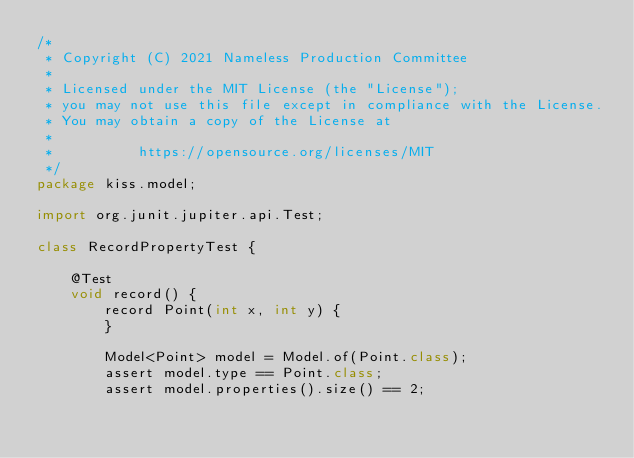<code> <loc_0><loc_0><loc_500><loc_500><_Java_>/*
 * Copyright (C) 2021 Nameless Production Committee
 *
 * Licensed under the MIT License (the "License");
 * you may not use this file except in compliance with the License.
 * You may obtain a copy of the License at
 *
 *          https://opensource.org/licenses/MIT
 */
package kiss.model;

import org.junit.jupiter.api.Test;

class RecordPropertyTest {

    @Test
    void record() {
        record Point(int x, int y) {
        }

        Model<Point> model = Model.of(Point.class);
        assert model.type == Point.class;
        assert model.properties().size() == 2;
</code> 